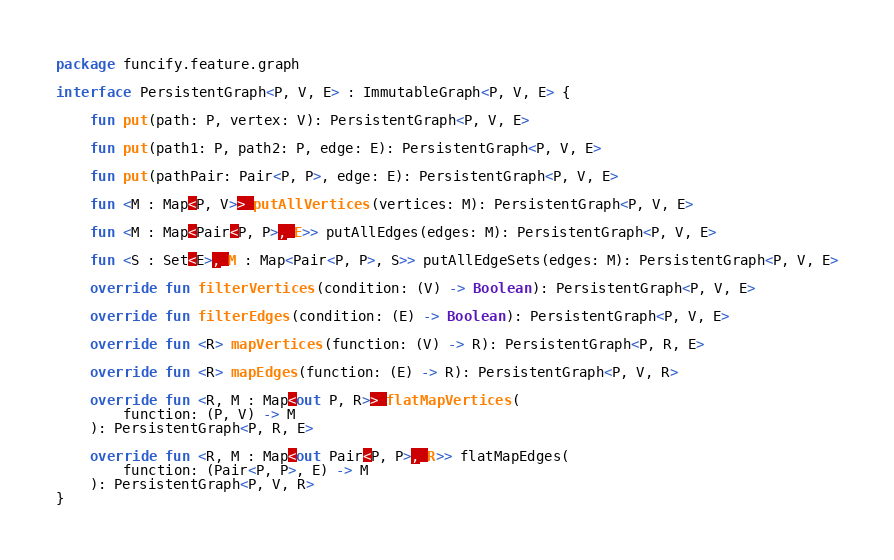<code> <loc_0><loc_0><loc_500><loc_500><_Kotlin_>package funcify.feature.graph

interface PersistentGraph<P, V, E> : ImmutableGraph<P, V, E> {

    fun put(path: P, vertex: V): PersistentGraph<P, V, E>

    fun put(path1: P, path2: P, edge: E): PersistentGraph<P, V, E>

    fun put(pathPair: Pair<P, P>, edge: E): PersistentGraph<P, V, E>

    fun <M : Map<P, V>> putAllVertices(vertices: M): PersistentGraph<P, V, E>

    fun <M : Map<Pair<P, P>, E>> putAllEdges(edges: M): PersistentGraph<P, V, E>

    fun <S : Set<E>, M : Map<Pair<P, P>, S>> putAllEdgeSets(edges: M): PersistentGraph<P, V, E>

    override fun filterVertices(condition: (V) -> Boolean): PersistentGraph<P, V, E>

    override fun filterEdges(condition: (E) -> Boolean): PersistentGraph<P, V, E>

    override fun <R> mapVertices(function: (V) -> R): PersistentGraph<P, R, E>

    override fun <R> mapEdges(function: (E) -> R): PersistentGraph<P, V, R>

    override fun <R, M : Map<out P, R>> flatMapVertices(
        function: (P, V) -> M
    ): PersistentGraph<P, R, E>

    override fun <R, M : Map<out Pair<P, P>, R>> flatMapEdges(
        function: (Pair<P, P>, E) -> M
    ): PersistentGraph<P, V, R>
}
</code> 